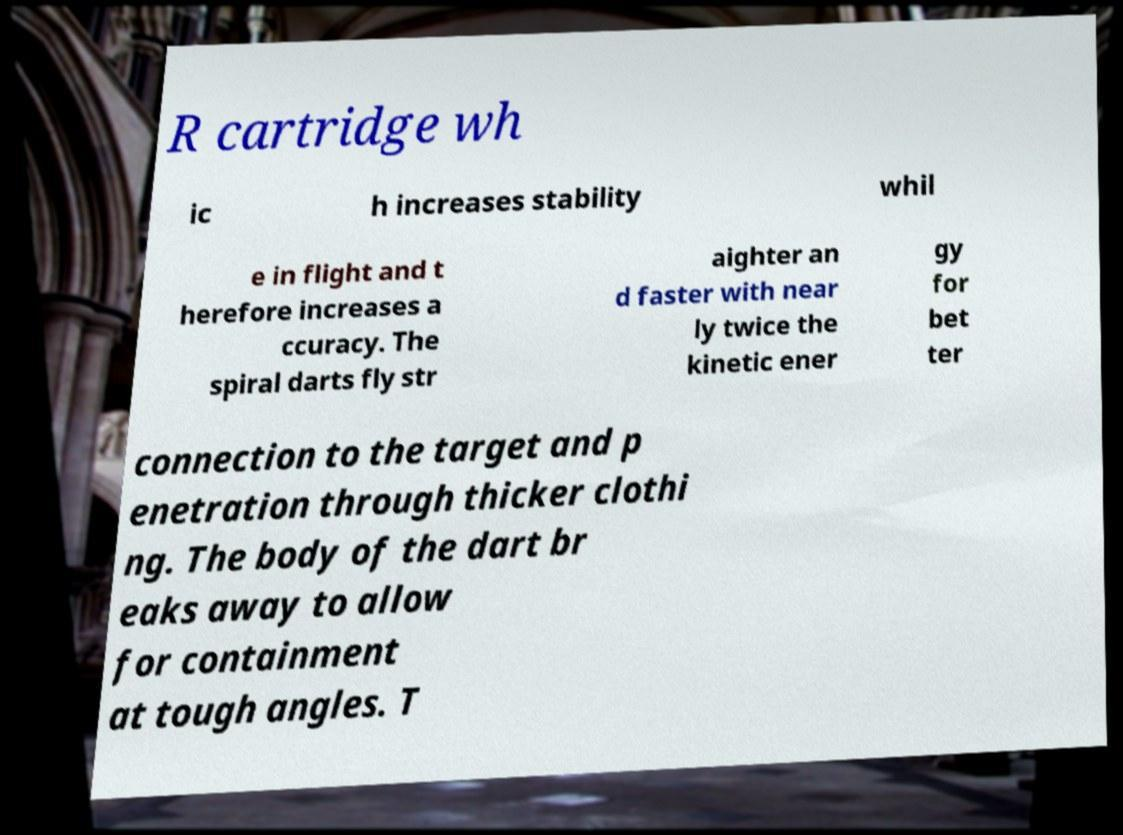Can you accurately transcribe the text from the provided image for me? R cartridge wh ic h increases stability whil e in flight and t herefore increases a ccuracy. The spiral darts fly str aighter an d faster with near ly twice the kinetic ener gy for bet ter connection to the target and p enetration through thicker clothi ng. The body of the dart br eaks away to allow for containment at tough angles. T 